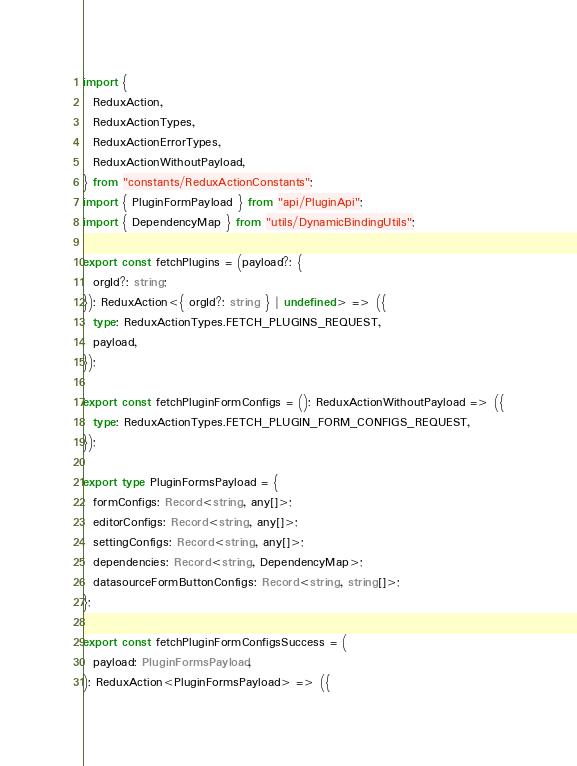Convert code to text. <code><loc_0><loc_0><loc_500><loc_500><_TypeScript_>import {
  ReduxAction,
  ReduxActionTypes,
  ReduxActionErrorTypes,
  ReduxActionWithoutPayload,
} from "constants/ReduxActionConstants";
import { PluginFormPayload } from "api/PluginApi";
import { DependencyMap } from "utils/DynamicBindingUtils";

export const fetchPlugins = (payload?: {
  orgId?: string;
}): ReduxAction<{ orgId?: string } | undefined> => ({
  type: ReduxActionTypes.FETCH_PLUGINS_REQUEST,
  payload,
});

export const fetchPluginFormConfigs = (): ReduxActionWithoutPayload => ({
  type: ReduxActionTypes.FETCH_PLUGIN_FORM_CONFIGS_REQUEST,
});

export type PluginFormsPayload = {
  formConfigs: Record<string, any[]>;
  editorConfigs: Record<string, any[]>;
  settingConfigs: Record<string, any[]>;
  dependencies: Record<string, DependencyMap>;
  datasourceFormButtonConfigs: Record<string, string[]>;
};

export const fetchPluginFormConfigsSuccess = (
  payload: PluginFormsPayload,
): ReduxAction<PluginFormsPayload> => ({</code> 